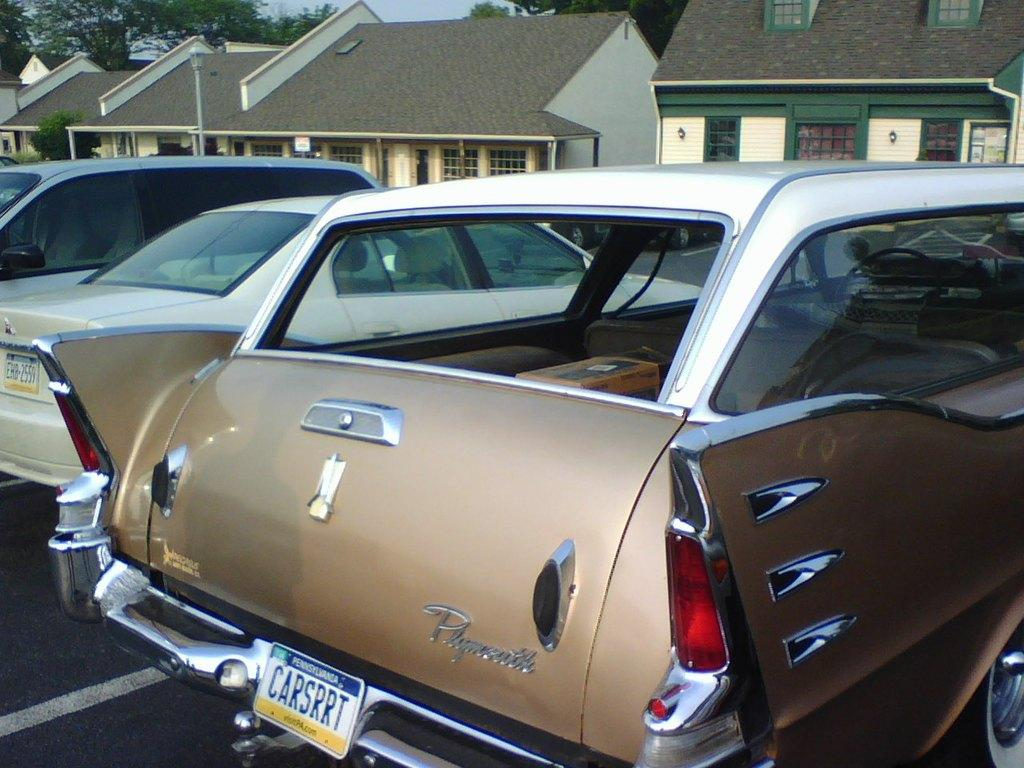What is the main subject in the center of the image? There are cars in the center of the image. What can be seen in the background of the image? There are trees and buildings in the background of the image. What type of crime is being committed in the image? There is no indication of any crime being committed in the image; it simply shows cars, trees, and buildings. 